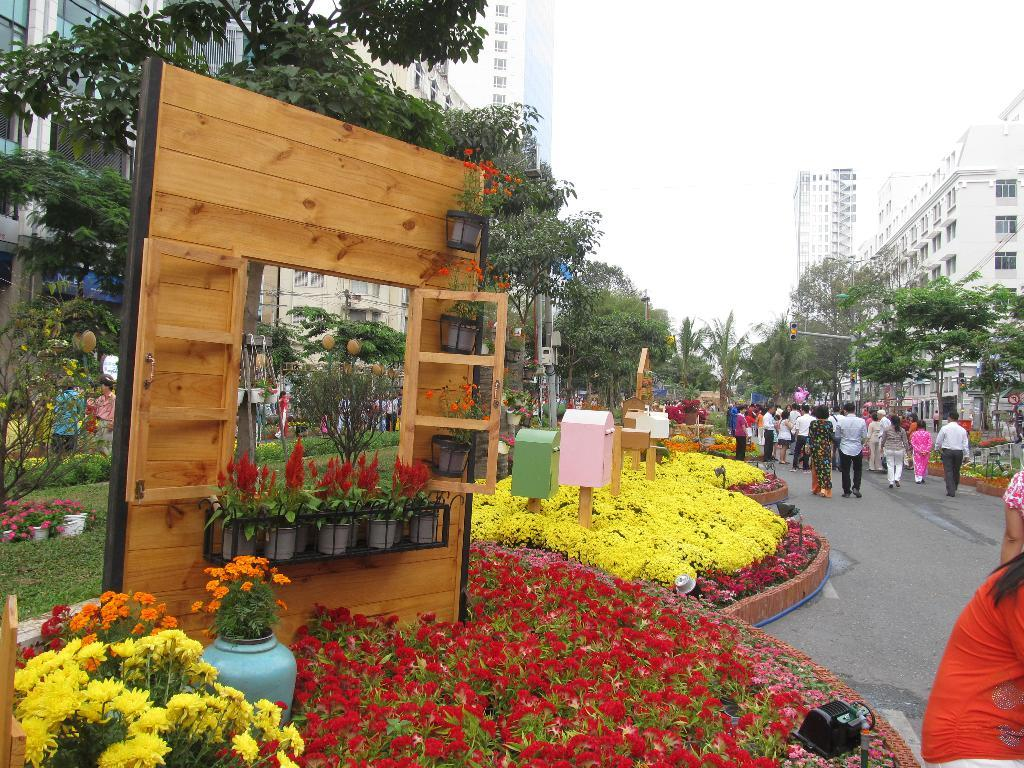What type of flora can be seen in the image? There are flowers, flower pots, and plants in the image. What is the setting of the image? The image features trees and buildings in the background, suggesting an outdoor or urban environment. What is visible in the sky in the image? The sky is clear and visible in the background of the image. What type of prose is being recited by the flowers in the image? There is no indication in the image that the flowers are reciting any prose, as flowers do not have the ability to speak or recite literature. 